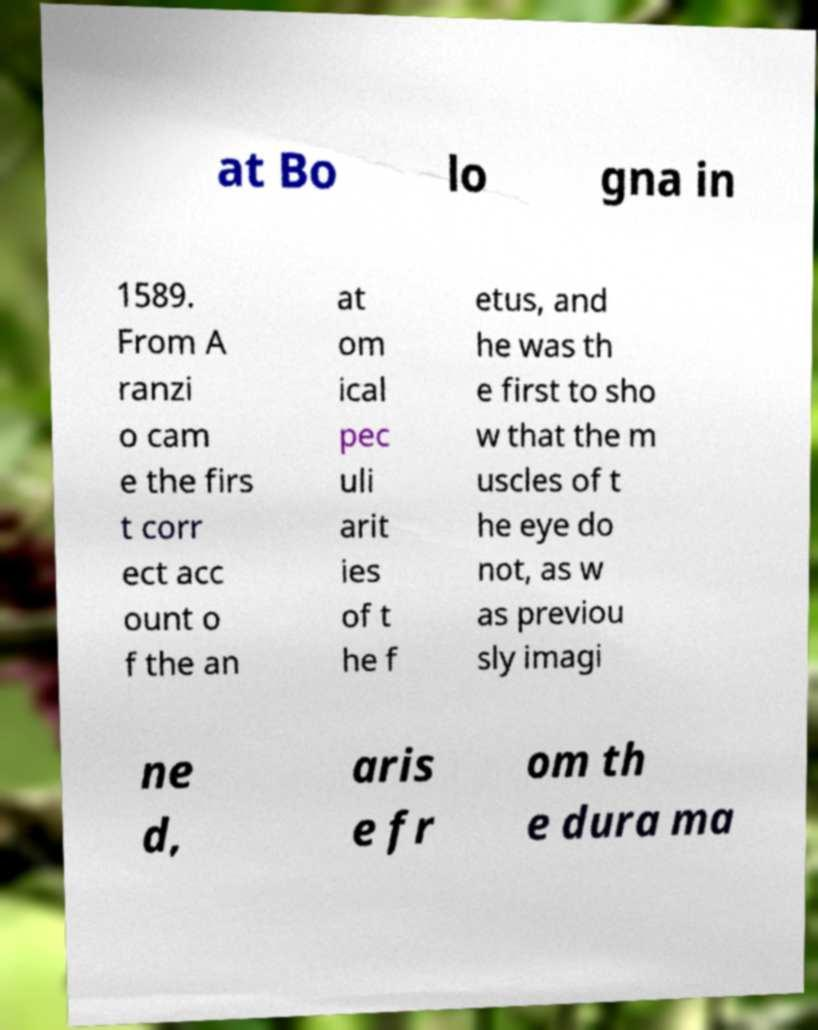Can you read and provide the text displayed in the image?This photo seems to have some interesting text. Can you extract and type it out for me? at Bo lo gna in 1589. From A ranzi o cam e the firs t corr ect acc ount o f the an at om ical pec uli arit ies of t he f etus, and he was th e first to sho w that the m uscles of t he eye do not, as w as previou sly imagi ne d, aris e fr om th e dura ma 